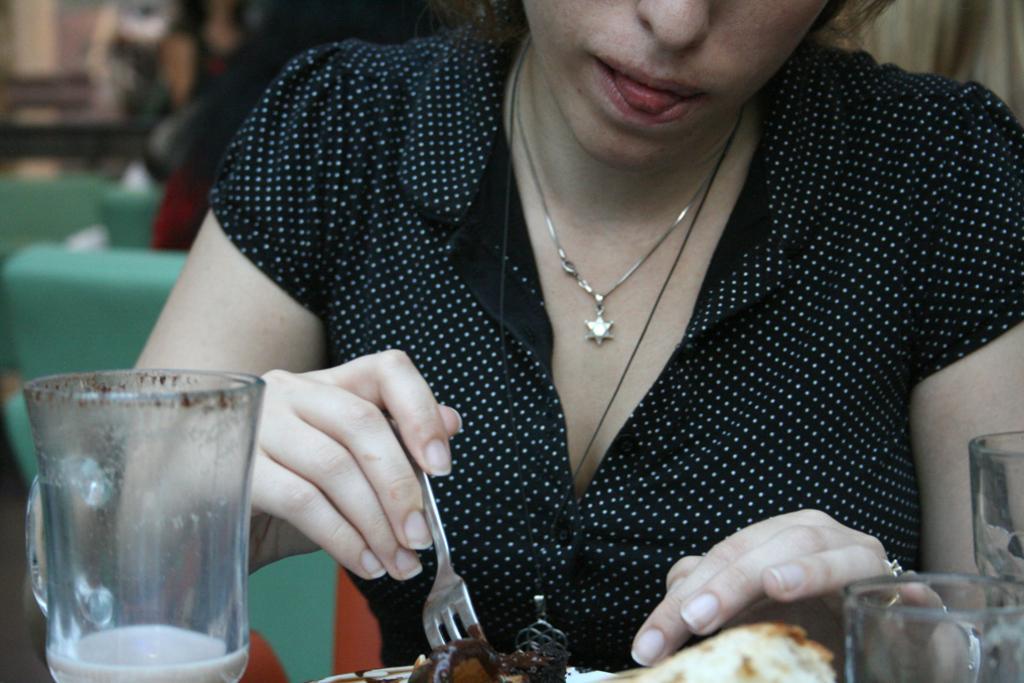How would you summarize this image in a sentence or two? In the image there is a woman eating some food item and around the food item there are some glasses. 